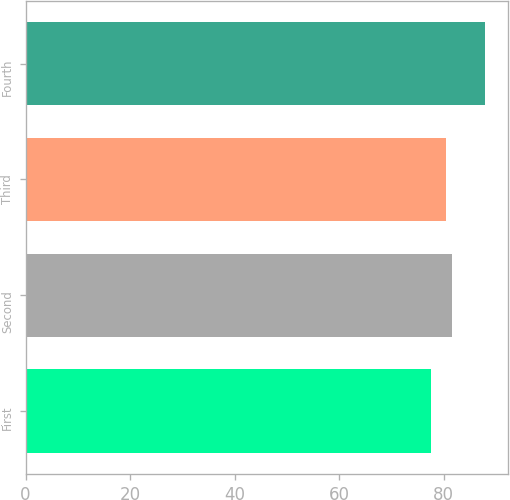Convert chart. <chart><loc_0><loc_0><loc_500><loc_500><bar_chart><fcel>First<fcel>Second<fcel>Third<fcel>Fourth<nl><fcel>77.51<fcel>81.53<fcel>80.49<fcel>87.95<nl></chart> 